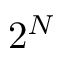<formula> <loc_0><loc_0><loc_500><loc_500>2 ^ { N }</formula> 